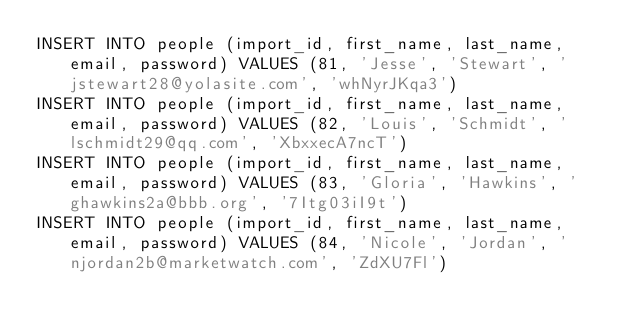Convert code to text. <code><loc_0><loc_0><loc_500><loc_500><_SQL_>INSERT INTO people (import_id, first_name, last_name, email, password) VALUES (81, 'Jesse', 'Stewart', 'jstewart28@yolasite.com', 'whNyrJKqa3')
INSERT INTO people (import_id, first_name, last_name, email, password) VALUES (82, 'Louis', 'Schmidt', 'lschmidt29@qq.com', 'XbxxecA7ncT')
INSERT INTO people (import_id, first_name, last_name, email, password) VALUES (83, 'Gloria', 'Hawkins', 'ghawkins2a@bbb.org', '7Itg03iI9t')
INSERT INTO people (import_id, first_name, last_name, email, password) VALUES (84, 'Nicole', 'Jordan', 'njordan2b@marketwatch.com', 'ZdXU7Fl')</code> 